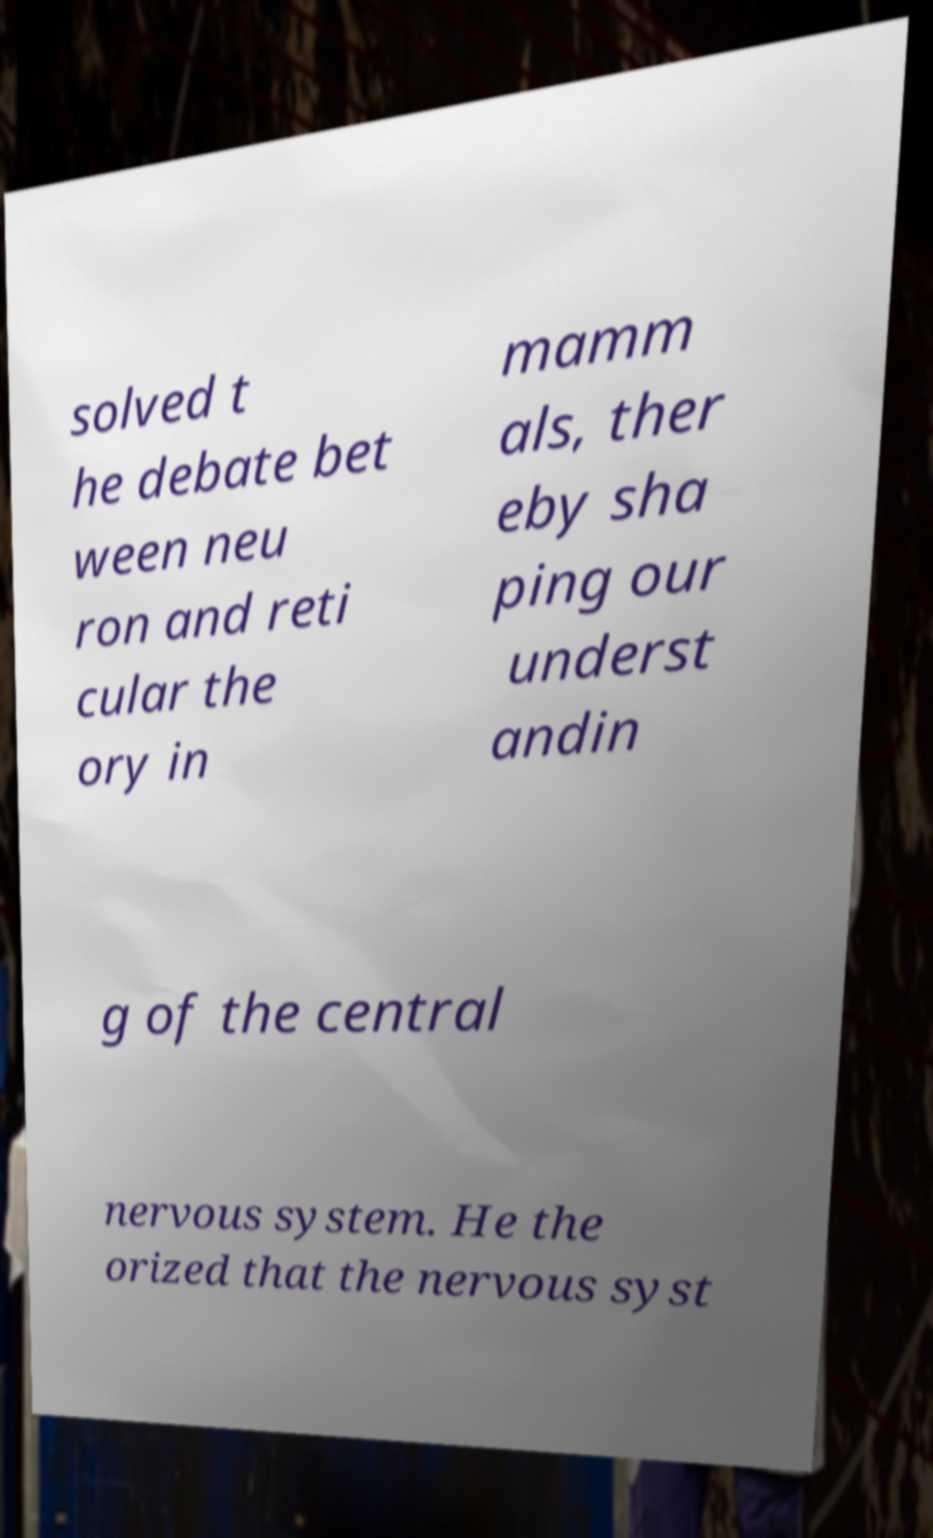There's text embedded in this image that I need extracted. Can you transcribe it verbatim? solved t he debate bet ween neu ron and reti cular the ory in mamm als, ther eby sha ping our underst andin g of the central nervous system. He the orized that the nervous syst 